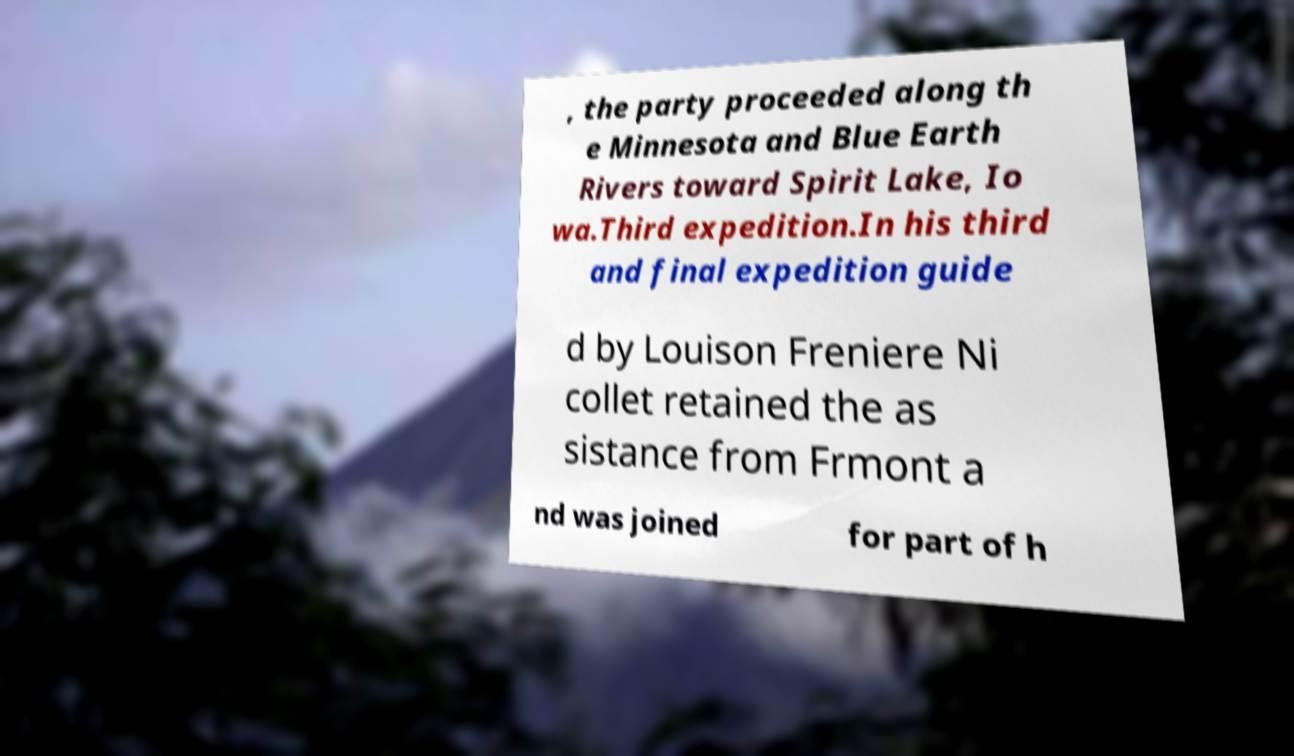There's text embedded in this image that I need extracted. Can you transcribe it verbatim? , the party proceeded along th e Minnesota and Blue Earth Rivers toward Spirit Lake, Io wa.Third expedition.In his third and final expedition guide d by Louison Freniere Ni collet retained the as sistance from Frmont a nd was joined for part of h 